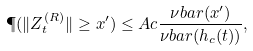<formula> <loc_0><loc_0><loc_500><loc_500>\P ( \| Z _ { t } ^ { ( R ) } \| \geq x ^ { \prime } ) \leq A c \frac { \nu b a r ( x ^ { \prime } ) } { \nu b a r ( h _ { c } ( t ) ) } ,</formula> 